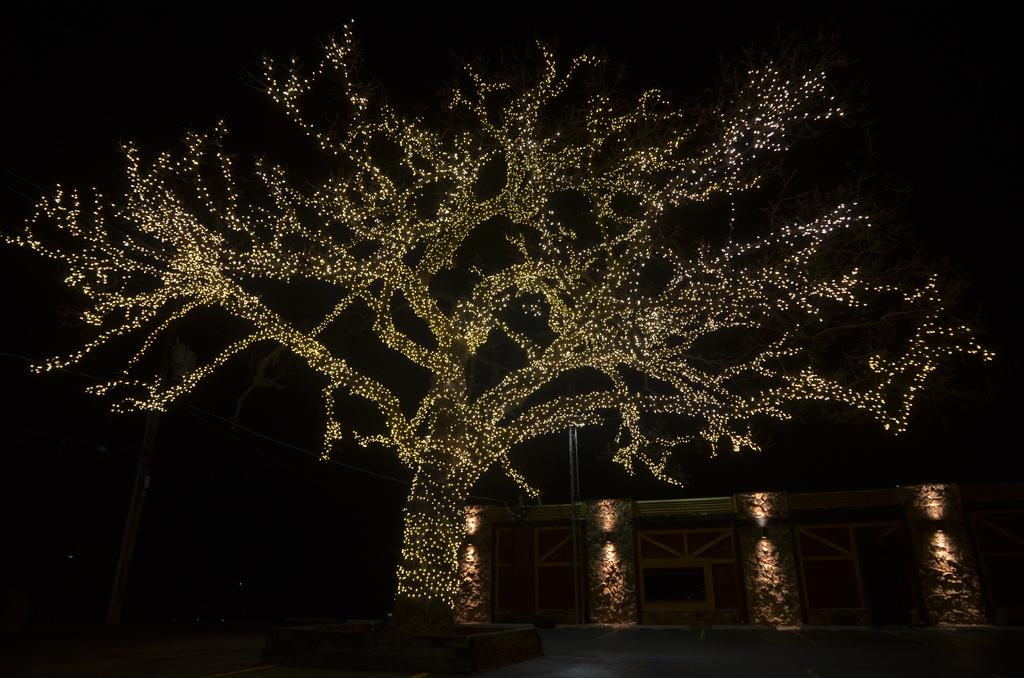What type of structure can be seen in the image? There is a wall in the image. What else is present in the image besides the wall? There are poles, wires, lights, and a tree decorated with lights in the image. How are the lights arranged in the image? The lights are arranged on the poles, wires, and the tree. What is the color of the background in the image? The background of the image is dark. How many eyes can be seen on the ghost in the image? There is no ghost present in the image, so it is not possible to determine the number of eyes. 